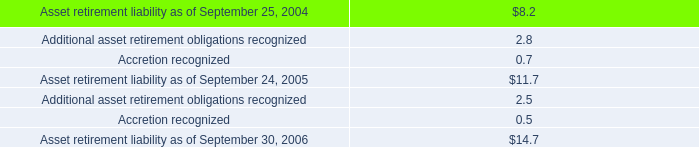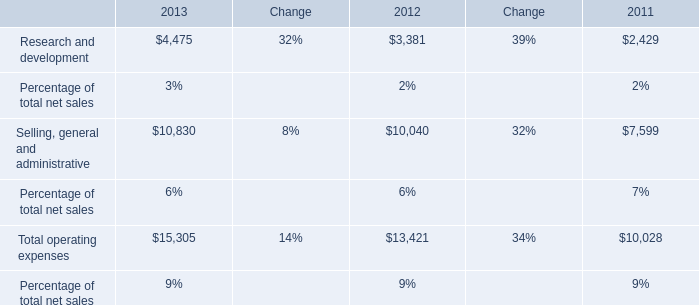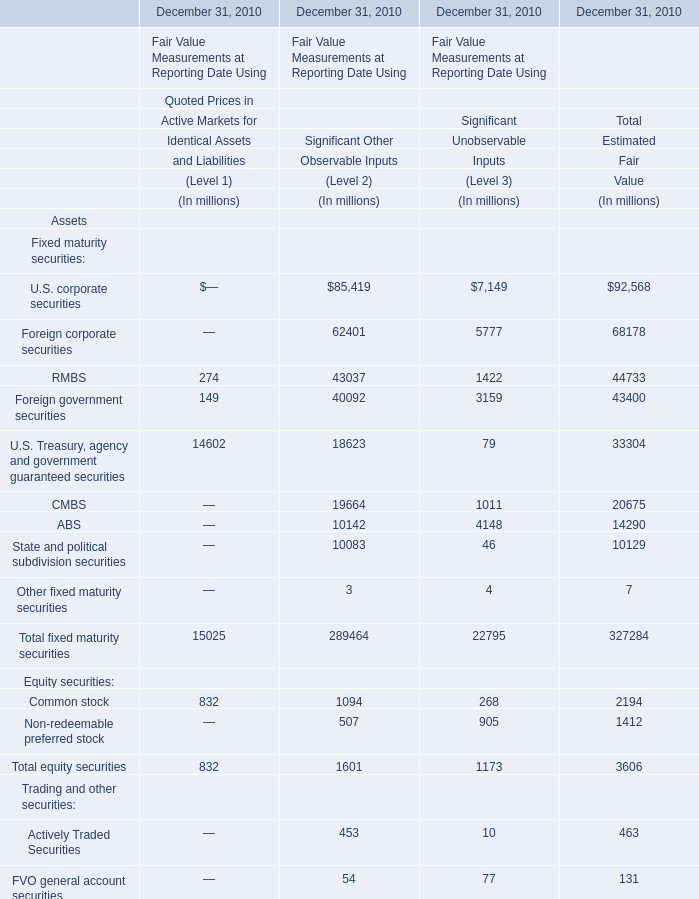How many equity securities for total estimated fair value exceed the average of equity securities for total estimated fair value in 2010? 
Computations: ((2194 + 1412) / 2)
Answer: 1803.0. 